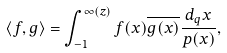Convert formula to latex. <formula><loc_0><loc_0><loc_500><loc_500>\langle f , g \rangle = \int _ { - 1 } ^ { \infty ( z ) } f ( x ) { \overline { g ( x ) } } \frac { d _ { q } x } { p ( x ) } ,</formula> 